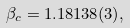Convert formula to latex. <formula><loc_0><loc_0><loc_500><loc_500>\beta _ { c } = 1 . 1 8 1 3 8 ( 3 ) ,</formula> 